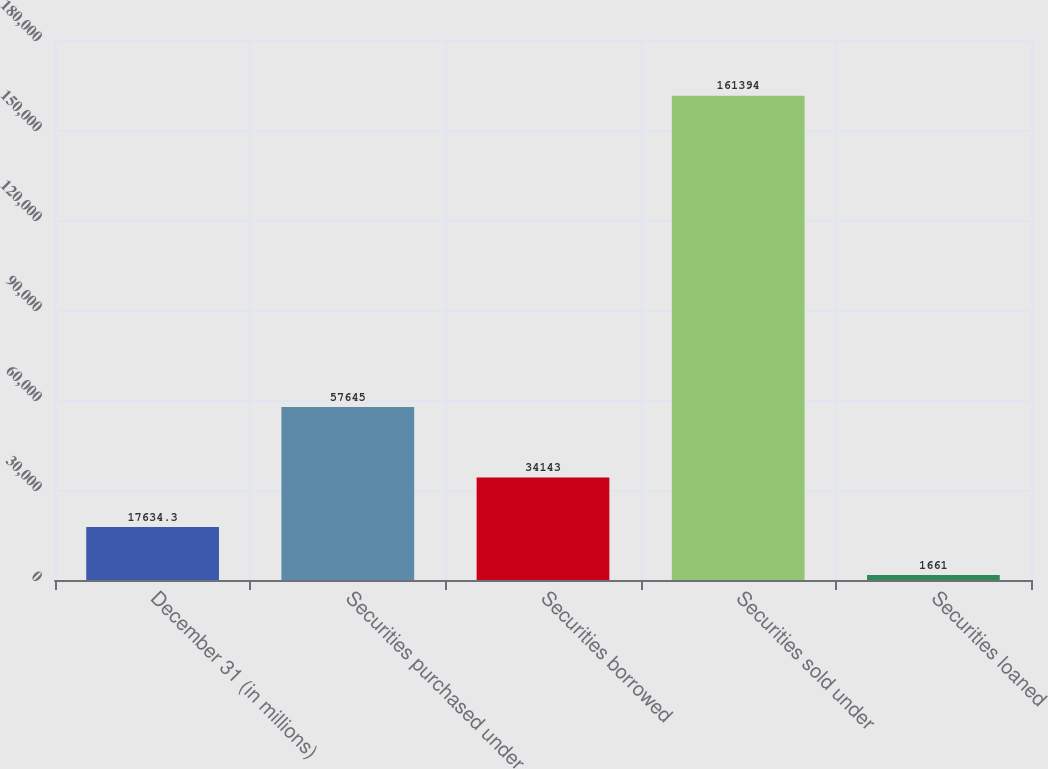Convert chart to OTSL. <chart><loc_0><loc_0><loc_500><loc_500><bar_chart><fcel>December 31 (in millions)<fcel>Securities purchased under<fcel>Securities borrowed<fcel>Securities sold under<fcel>Securities loaned<nl><fcel>17634.3<fcel>57645<fcel>34143<fcel>161394<fcel>1661<nl></chart> 